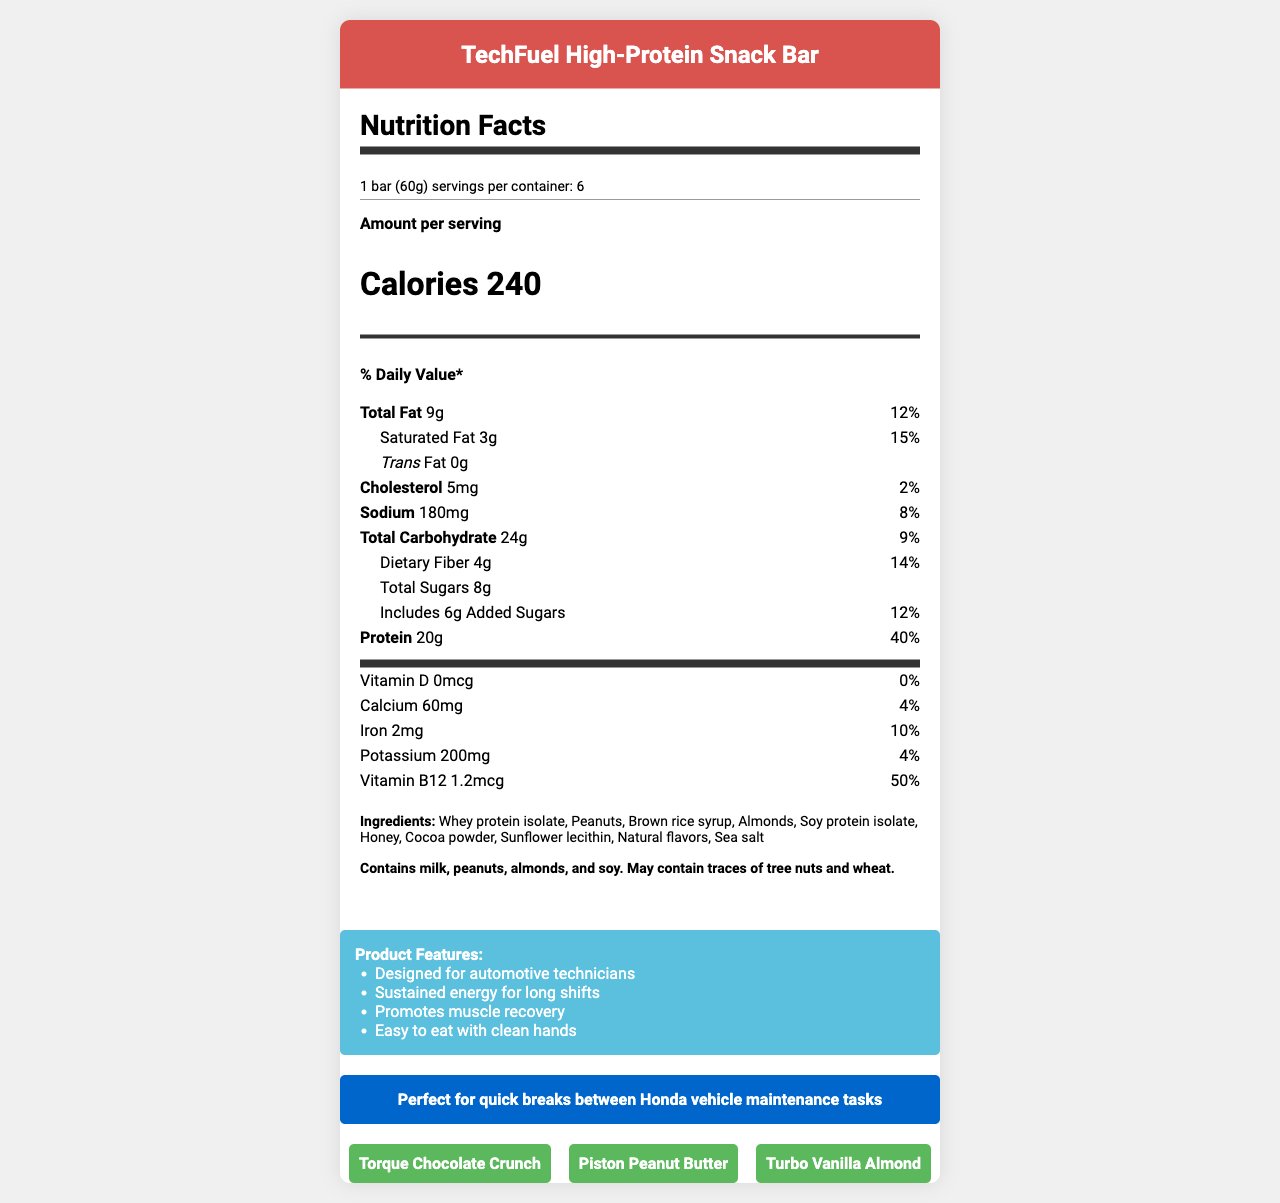What is the serving size of the TechFuel High-Protein Snack Bar? The serving size is stated at the beginning of the Nutrition Facts section.
Answer: 1 bar (60g) How many servings are there per container? The document states that there are 6 servings per container.
Answer: 6 How many calories does one TechFuel High-Protein Snack Bar contain? The calorie content is listed directly in the document's Nutrition Facts section.
Answer: 240 What is the total fat content per serving? The total fat content per serving is provided in the Nutrition Facts section under Total Fat.
Answer: 9g What percentage of the daily value for protein does one serving provide? This information is listed under the protein section of the Nutrition Facts.
Answer: 40% Which mineral has the highest percentage daily value in one serving of the snack bar? A. Calcium B. Iron C. Potassium Iron has a daily value percentage of 10%, which is higher than both calcium (4%) and potassium (4%).
Answer: B. Iron What is the primary protein source in the TechFuel High-Protein Snack Bar? A. Whey Protein Isolate B. Soy Protein Isolate C. Almonds D. Peanuts Whey protein isolate is listed first in the ingredients, indicating it's the primary protein source.
Answer: A. Whey Protein Isolate How much dietary fiber does one serving contain? The dietary fiber content per serving is provided under Total Carbohydrate in the Nutrition Facts.
Answer: 4g True or False: The TechFuel High-Protein Snack Bar contains no trans fat. The Nutrition Facts section explicitly states that the trans fat content is 0g.
Answer: True Summarize the main idea of the document. The document aims to present comprehensive nutrition and product information for a specialized high-protein snack bar designed for automotive technicians, emphasizing its practicality, health benefits, and themed flavors.
Answer: The document provides detailed nutrition facts for the TechFuel High-Protein Snack Bar, highlighting its suitability for automotive technicians with its sustained energy, muscle recovery benefits, and convenience for quick breaks. It lists the nutritional content, ingredients, allergen information, marketing claims, and specific automotive-themed flavors. What flavors of the TechFuel High-Protein Snack Bar are available? The document lists three automotive-themed flavors under the flavors section.
Answer: Torque Chocolate Crunch, Piston Peanut Butter, Turbo Vanilla Almond How much calcium does one serving of the TechFuel High-Protein Snack Bar provide? Calcium content per serving is directly listed in the Nutrition Facts section.
Answer: 60mg Is there any Vitamin D in the TechFuel High-Protein Snack Bar? The document states that there is 0mcg of Vitamin D, indicating its absence in the snack bar.
Answer: No What ingredients are used in the TechFuel High-Protein Snack Bar? The ingredients are listed in the ingredients section of the document.
Answer: Whey protein isolate, Peanuts, Brown rice syrup, Almonds, Soy protein isolate, Honey, Cocoa powder, Sunflower lecithin, Natural flavors, Sea salt How much sodium does each bar contain? The sodium content is listed in the Nutrition Facts section.
Answer: 180mg What is the marketing claim related to energy for the TechFuel High-Protein Snack Bar? The marketing claim emphasizing energy is listed in the marketing claims section.
Answer: Sustained energy for long shifts When is the TechFuel High-Protein Snack Bar recommended for automotive technicians? The document includes a Honda-specific recommendation for quick breaks between maintenance tasks.
Answer: Quick breaks between Honda vehicle maintenance tasks How much Vitamin B12 is there in the TechFuel High-Protein Snack Bar? The Vitamin B12 content is provided in the Nutrition Facts section.
Answer: 1.2mcg What are the allergens present in the TechFuel High-Protein Snack Bar? The allergen information is listed in a dedicated section towards the end of the Nutrition Facts.
Answer: Milk, peanuts, almonds, soy What is the main office address of the manufacturer? The document does not provide the manufacturer's main office address.
Answer: Not enough information 